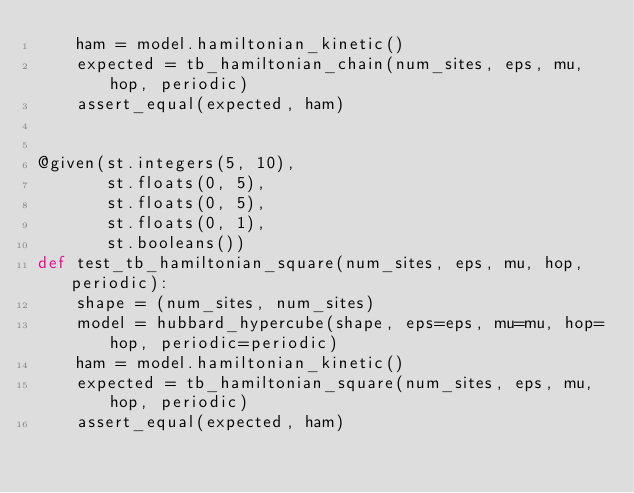<code> <loc_0><loc_0><loc_500><loc_500><_Python_>    ham = model.hamiltonian_kinetic()
    expected = tb_hamiltonian_chain(num_sites, eps, mu, hop, periodic)
    assert_equal(expected, ham)


@given(st.integers(5, 10),
       st.floats(0, 5),
       st.floats(0, 5),
       st.floats(0, 1),
       st.booleans())
def test_tb_hamiltonian_square(num_sites, eps, mu, hop, periodic):
    shape = (num_sites, num_sites)
    model = hubbard_hypercube(shape, eps=eps, mu=mu, hop=hop, periodic=periodic)
    ham = model.hamiltonian_kinetic()
    expected = tb_hamiltonian_square(num_sites, eps, mu, hop, periodic)
    assert_equal(expected, ham)
</code> 